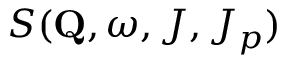<formula> <loc_0><loc_0><loc_500><loc_500>S ( Q , \omega , J , J _ { p } )</formula> 